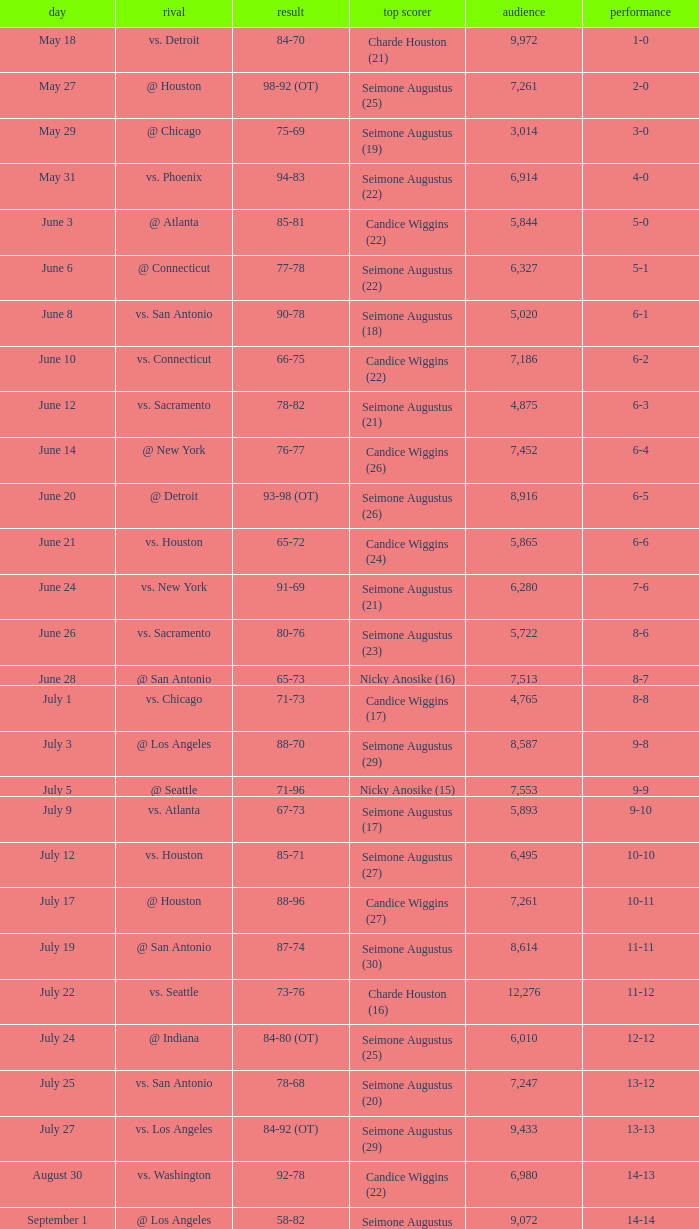Which Leading Scorer has an Opponent of @ seattle, and a Record of 14-16? Seimone Augustus (26). 